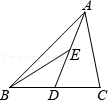First perform reasoning, then finally select the question from the choices in the following format: Answer: xxx.
Question: If in triangle ABC, point D is the midpoint of side BC and point E is the midpoint of side AD, and the area of triangle ABC measures 10 units, what is the area of triangle ABE?
Choices:
A: 1.25
B: 3
C: 2.5
D: 5 Let the area of triangle ABE be x. Since E is the midpoint of AD, then AE=DE. Therefore, the area of triangle ABE is equal to the area of triangle BDE, which is x. Since D is the midpoint of BC, then BD=CD. Therefore, the area of triangle ABD is equal to the area of triangle ADC, which is 2x. Therefore, the area of triangle ABC is 4x, which is equal to 10. Therefore, x=2.5. Therefore, the correct answer is C.
Answer:C 